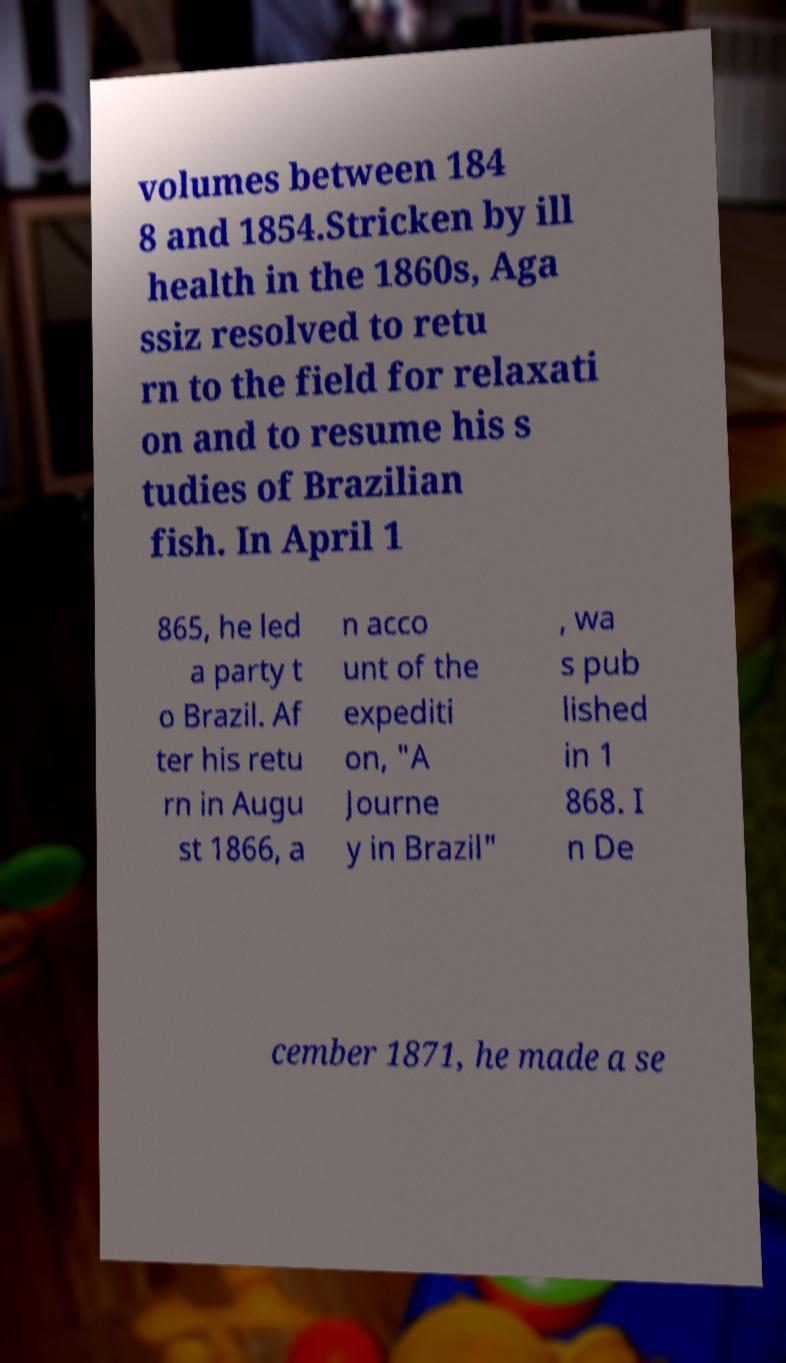Can you accurately transcribe the text from the provided image for me? volumes between 184 8 and 1854.Stricken by ill health in the 1860s, Aga ssiz resolved to retu rn to the field for relaxati on and to resume his s tudies of Brazilian fish. In April 1 865, he led a party t o Brazil. Af ter his retu rn in Augu st 1866, a n acco unt of the expediti on, "A Journe y in Brazil" , wa s pub lished in 1 868. I n De cember 1871, he made a se 